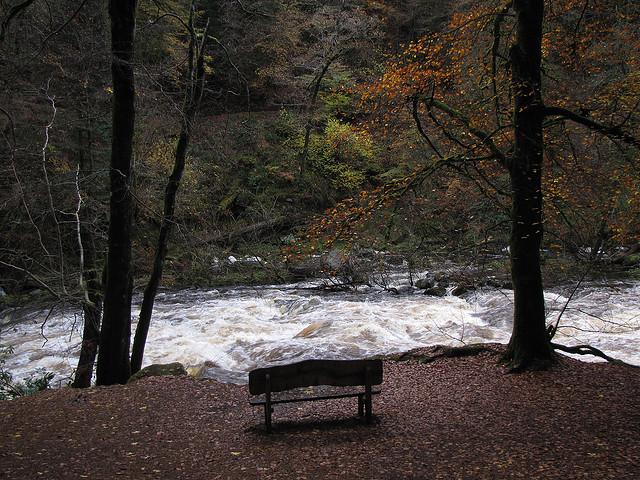Could this river ever reach the bench in a storm?
Quick response, please. Yes. Is the river considered rough?
Write a very short answer. Yes. Has something moved through the water?
Answer briefly. No. What is flowing through the picture?
Write a very short answer. Water. What is next to the bench?
Concise answer only. Trees. 